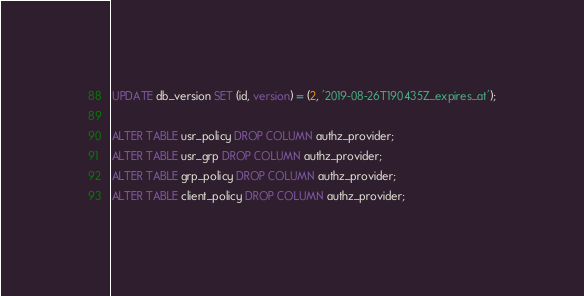<code> <loc_0><loc_0><loc_500><loc_500><_SQL_>UPDATE db_version SET (id, version) = (2, '2019-08-26T190435Z_expires_at');

ALTER TABLE usr_policy DROP COLUMN authz_provider;
ALTER TABLE usr_grp DROP COLUMN authz_provider;
ALTER TABLE grp_policy DROP COLUMN authz_provider;
ALTER TABLE client_policy DROP COLUMN authz_provider;
</code> 